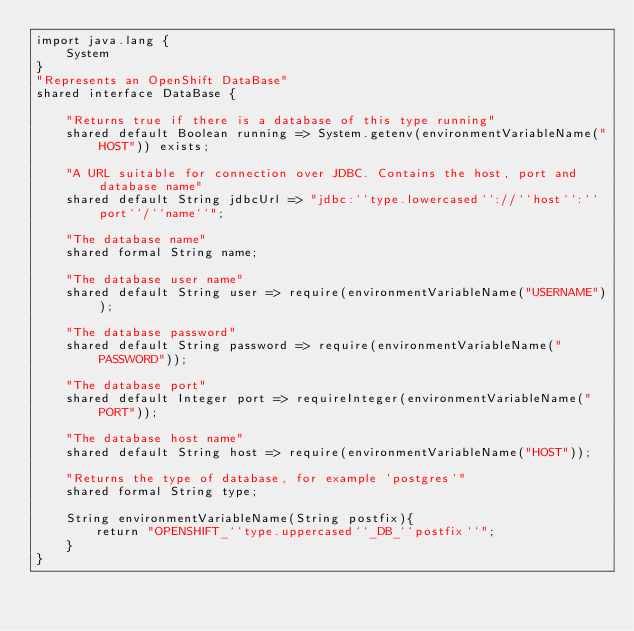Convert code to text. <code><loc_0><loc_0><loc_500><loc_500><_Ceylon_>import java.lang {
    System
}
"Represents an OpenShift DataBase"
shared interface DataBase {
    
    "Returns true if there is a database of this type running"
    shared default Boolean running => System.getenv(environmentVariableName("HOST")) exists;
    
    "A URL suitable for connection over JDBC. Contains the host, port and database name"
    shared default String jdbcUrl => "jdbc:``type.lowercased``://``host``:``port``/``name``";
    
    "The database name"
    shared formal String name;
    
    "The database user name"
    shared default String user => require(environmentVariableName("USERNAME"));
    
    "The database password"
    shared default String password => require(environmentVariableName("PASSWORD"));
    
    "The database port"
    shared default Integer port => requireInteger(environmentVariableName("PORT"));
    
    "The database host name"
    shared default String host => require(environmentVariableName("HOST"));
    
    "Returns the type of database, for example `postgres`"
    shared formal String type;

    String environmentVariableName(String postfix){
        return "OPENSHIFT_``type.uppercased``_DB_``postfix``";
    }
}</code> 